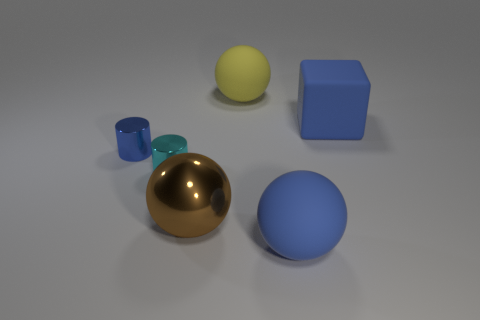Add 3 big balls. How many objects exist? 9 Subtract all matte spheres. How many spheres are left? 1 Subtract 1 cubes. How many cubes are left? 0 Subtract all cylinders. How many objects are left? 4 Subtract all cyan cylinders. How many cylinders are left? 1 Subtract 0 purple cubes. How many objects are left? 6 Subtract all brown cylinders. Subtract all blue blocks. How many cylinders are left? 2 Subtract all blue metal objects. Subtract all cyan shiny cylinders. How many objects are left? 4 Add 4 blue cylinders. How many blue cylinders are left? 5 Add 6 large gray things. How many large gray things exist? 6 